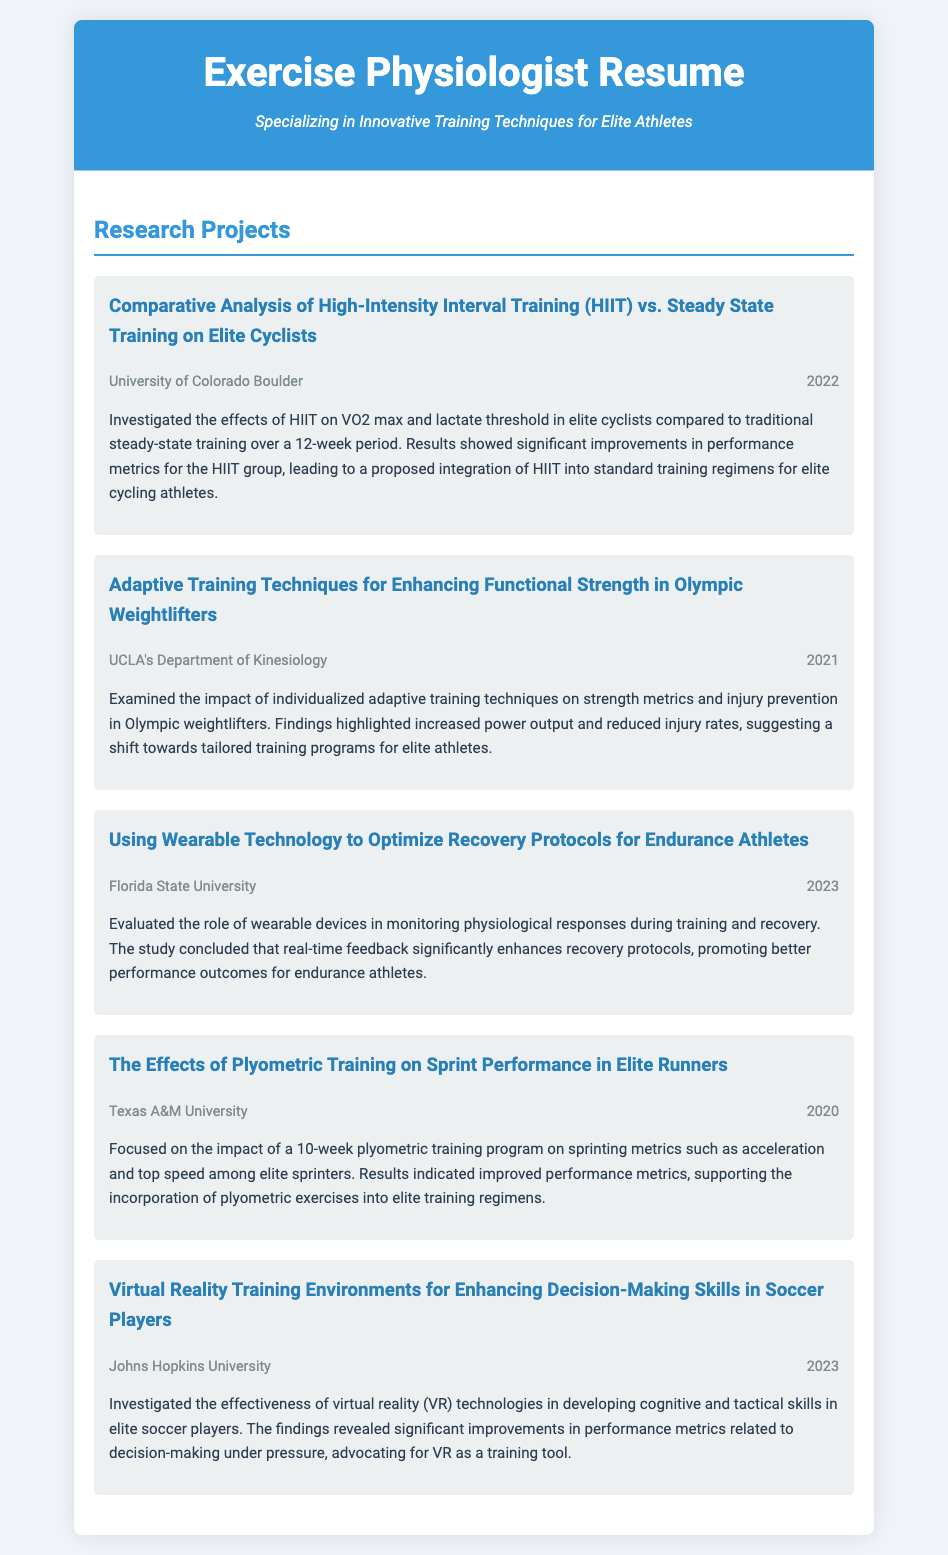What is the title of the research project conducted at the University of Colorado Boulder? The title of the research project is "Comparative Analysis of High-Intensity Interval Training (HIIT) vs. Steady State Training on Elite Cyclists."
Answer: Comparative Analysis of High-Intensity Interval Training (HIIT) vs. Steady State Training on Elite Cyclists In which year was the adaptive training techniques study conducted? The study on adaptive training techniques for Olympic weightlifters was conducted in 2021.
Answer: 2021 What was the focus of the project at Florida State University? The project focused on using wearable technology to optimize recovery protocols for endurance athletes.
Answer: Using Wearable Technology to Optimize Recovery Protocols for Endurance Athletes Which training method was explored in relation to sprint performance at Texas A&M University? The project explored plyometric training in relation to sprint performance.
Answer: Plyometric training What significant finding was associated with the use of virtual reality technologies in soccer training? The significant finding was improvements in performance metrics related to decision-making under pressure.
Answer: Improvements in performance metrics related to decision-making under pressure How many weeks was the plyometric training program in the elite runners study? The plyometric training program lasted for 10 weeks.
Answer: 10 weeks Which university focused on investigating the impact of HIIT on cyclists? The University of Colorado Boulder focused on this research.
Answer: University of Colorado Boulder What was the main outcome sought from the study involving wearable devices? The main outcome was enhancing recovery protocols for better performance outcomes in endurance athletes.
Answer: Enhancing recovery protocols for better performance outcomes 